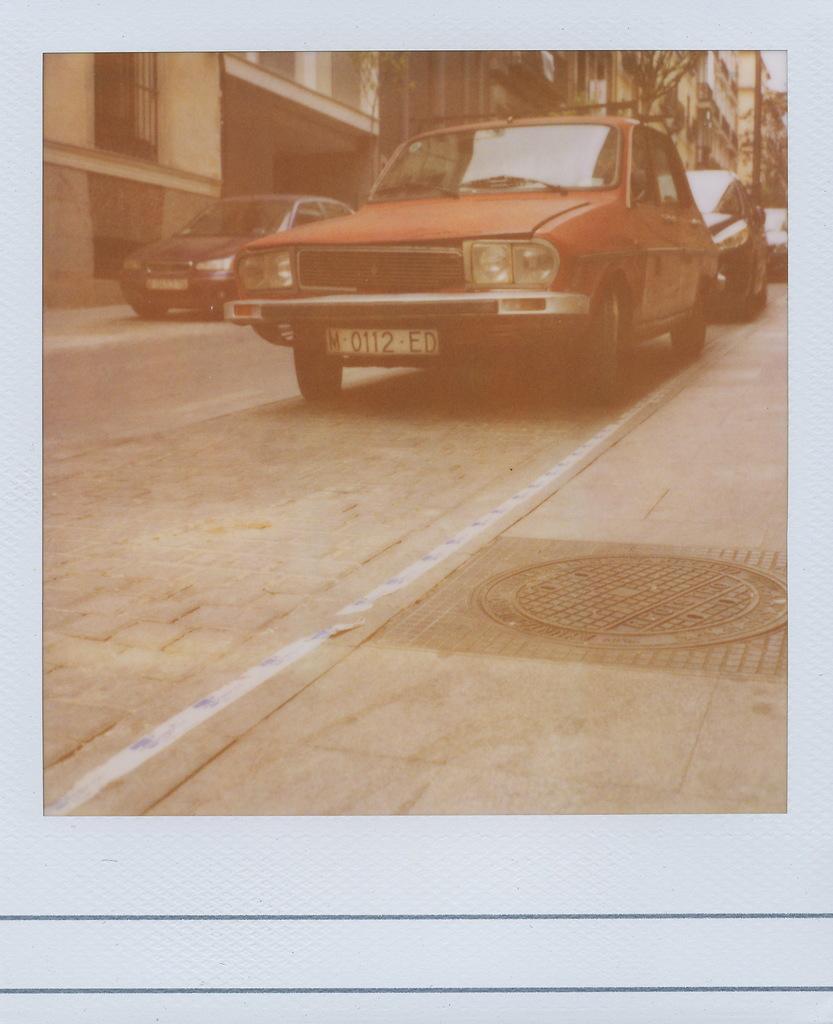In one or two sentences, can you explain what this image depicts? As we can see in the image there are cars and buildings. 